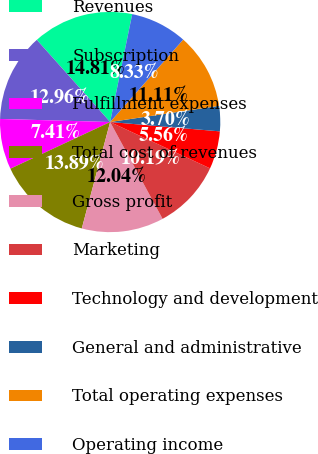<chart> <loc_0><loc_0><loc_500><loc_500><pie_chart><fcel>Revenues<fcel>Subscription<fcel>Fulfillment expenses<fcel>Total cost of revenues<fcel>Gross profit<fcel>Marketing<fcel>Technology and development<fcel>General and administrative<fcel>Total operating expenses<fcel>Operating income<nl><fcel>14.81%<fcel>12.96%<fcel>7.41%<fcel>13.89%<fcel>12.04%<fcel>10.19%<fcel>5.56%<fcel>3.7%<fcel>11.11%<fcel>8.33%<nl></chart> 